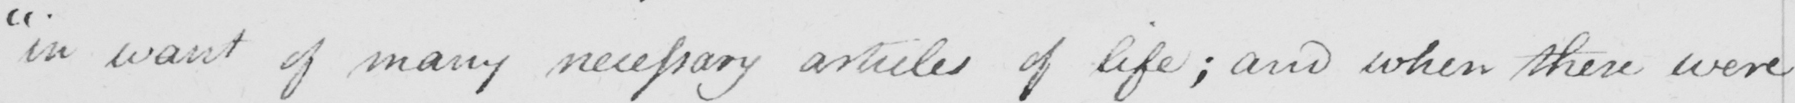What does this handwritten line say? " in want of many necessary articles of life ; and when there were 